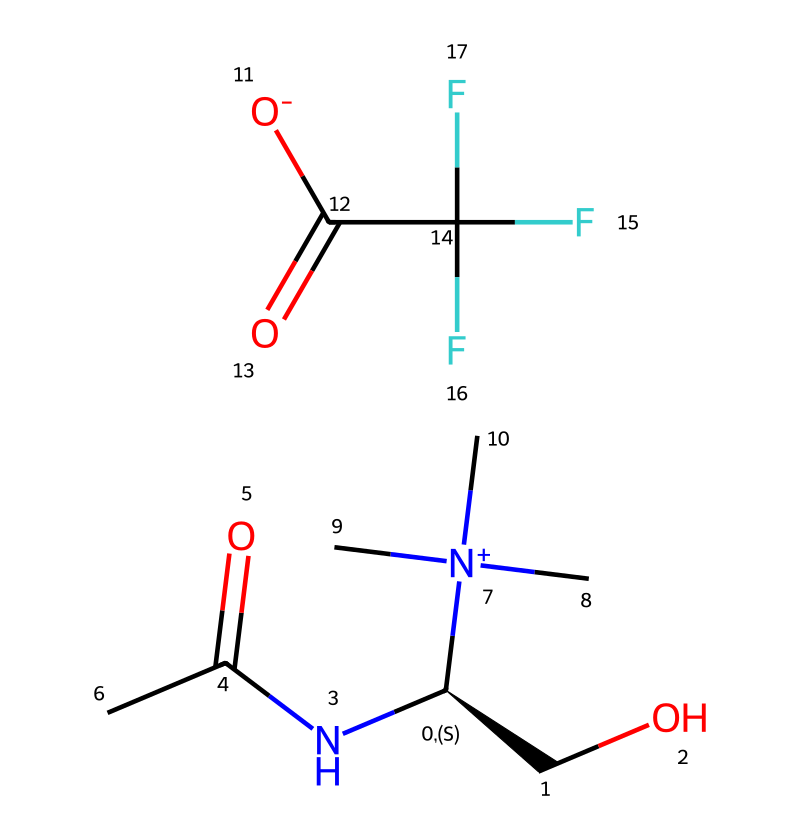What is the total number of carbon atoms in this ionic liquid? To count the carbon atoms, we look at the SMILES representation and identify each carbon (C). There are four distinct carbon atoms indicated in the structure.
Answer: four How many nitrogen atoms are present in the chemical? The SMILES notation shows a nitrogen atom (N) that appears twice within the structure. Therefore, the total nitrogen count is two.
Answer: two What type of functional groups are present in this ionic liquid? By analyzing the chemical structure, we see that there are amide (C(=O)N) and the trifluoromethyl group (C(F)(F)(F)). These indicate the presence of both amide and fluorinated functional groups.
Answer: amide, trifluoromethyl What is the charge of the ion associated with the N+ in this ionic liquid? The notation 'N+' signifies that the nitrogen is positively charged. In ionic liquids, cations are typically positively charged and anions are negatively charged, corroborating that the presence of the N+ indicates a cationic charge.
Answer: positive Which elements in the chemical structure suggest environmentally friendly properties? The presence of a carbonyl group (-C(=O)-) and an absence of heavy metals in the structure typically indicate environmentally friendly characteristics. The combination of non-toxic elements supports its classification as "green" chemistry.
Answer: carbonyl, non-toxic How many oxygen atoms are there in this ionic liquid's structure? The SMILES representation includes two oxygen atoms (O) located in the carbonyl groups, confirming the count to be two.
Answer: two What is the significance of having ionic character in this liquid? Ionic character in this liquid suggests enhanced solubility and stability in various solvents, correlating with efficient cleaning processes which makes ionic liquids preferred for industrial cleaning applications.
Answer: enhanced solubility, stability 